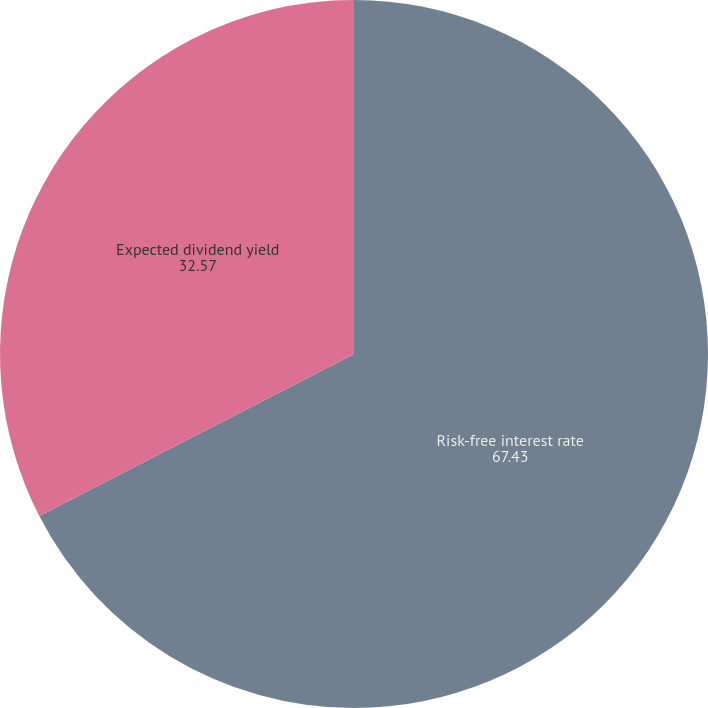Convert chart. <chart><loc_0><loc_0><loc_500><loc_500><pie_chart><fcel>Risk-free interest rate<fcel>Expected dividend yield<nl><fcel>67.43%<fcel>32.57%<nl></chart> 